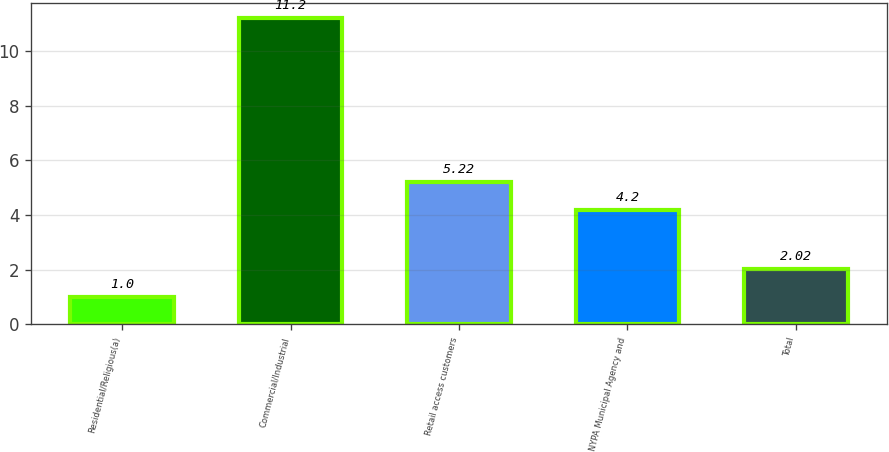<chart> <loc_0><loc_0><loc_500><loc_500><bar_chart><fcel>Residential/Religious(a)<fcel>Commercial/Industrial<fcel>Retail access customers<fcel>NYPA Municipal Agency and<fcel>Total<nl><fcel>1<fcel>11.2<fcel>5.22<fcel>4.2<fcel>2.02<nl></chart> 